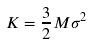<formula> <loc_0><loc_0><loc_500><loc_500>K = \frac { 3 } { 2 } M \sigma ^ { 2 }</formula> 